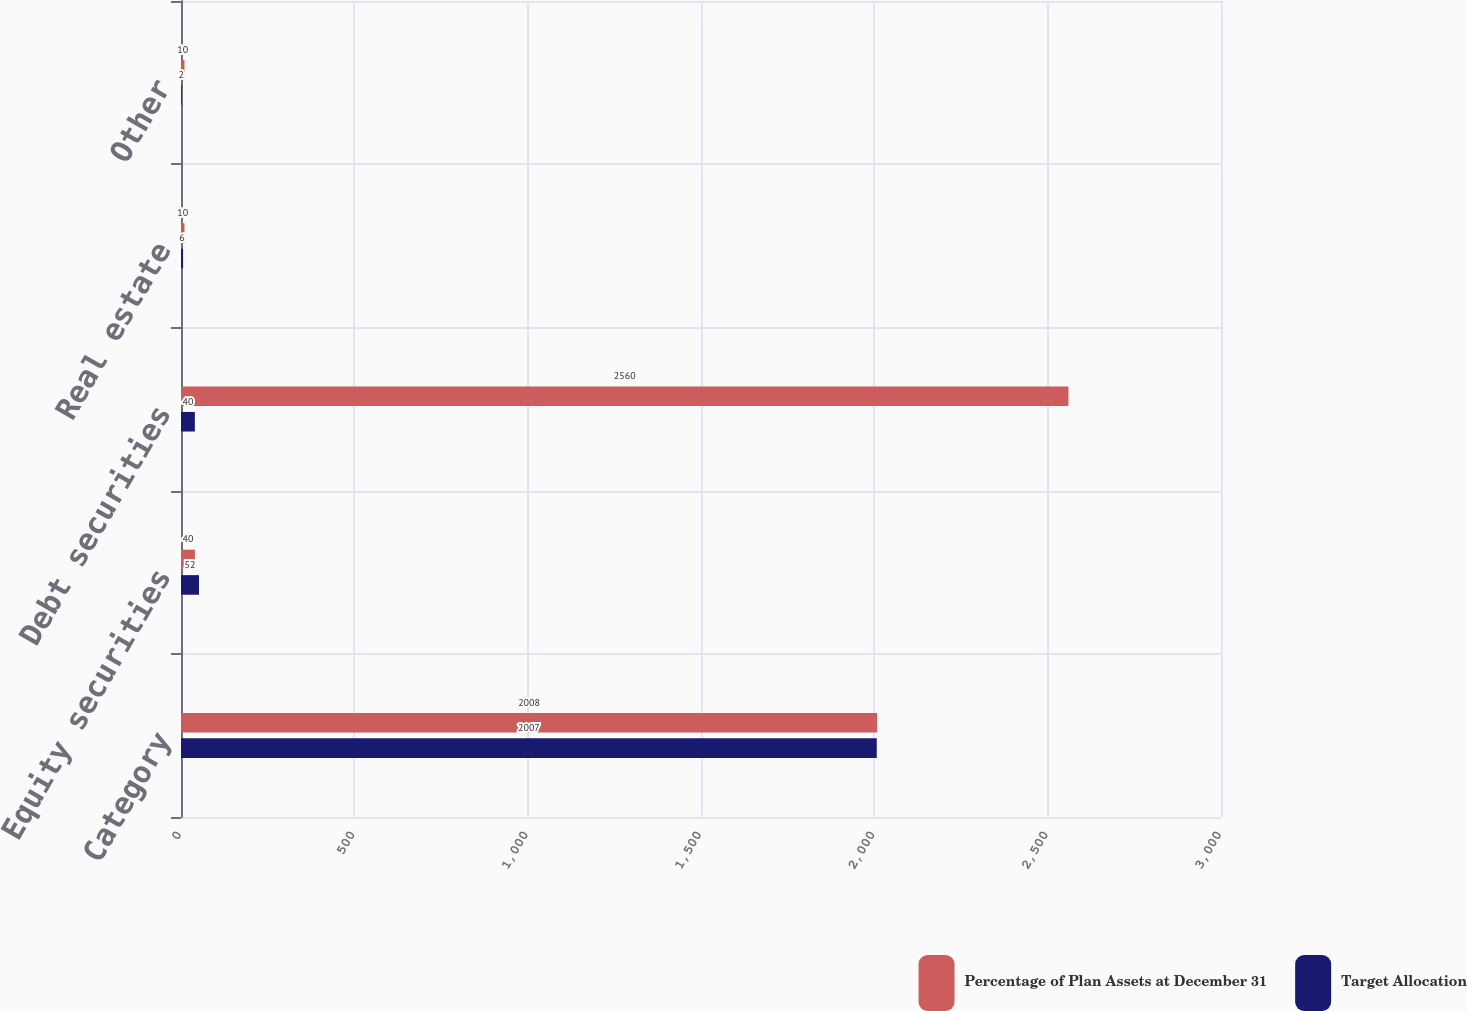<chart> <loc_0><loc_0><loc_500><loc_500><stacked_bar_chart><ecel><fcel>Category<fcel>Equity securities<fcel>Debt securities<fcel>Real estate<fcel>Other<nl><fcel>Percentage of Plan Assets at December 31<fcel>2008<fcel>40<fcel>2560<fcel>10<fcel>10<nl><fcel>Target Allocation<fcel>2007<fcel>52<fcel>40<fcel>6<fcel>2<nl></chart> 